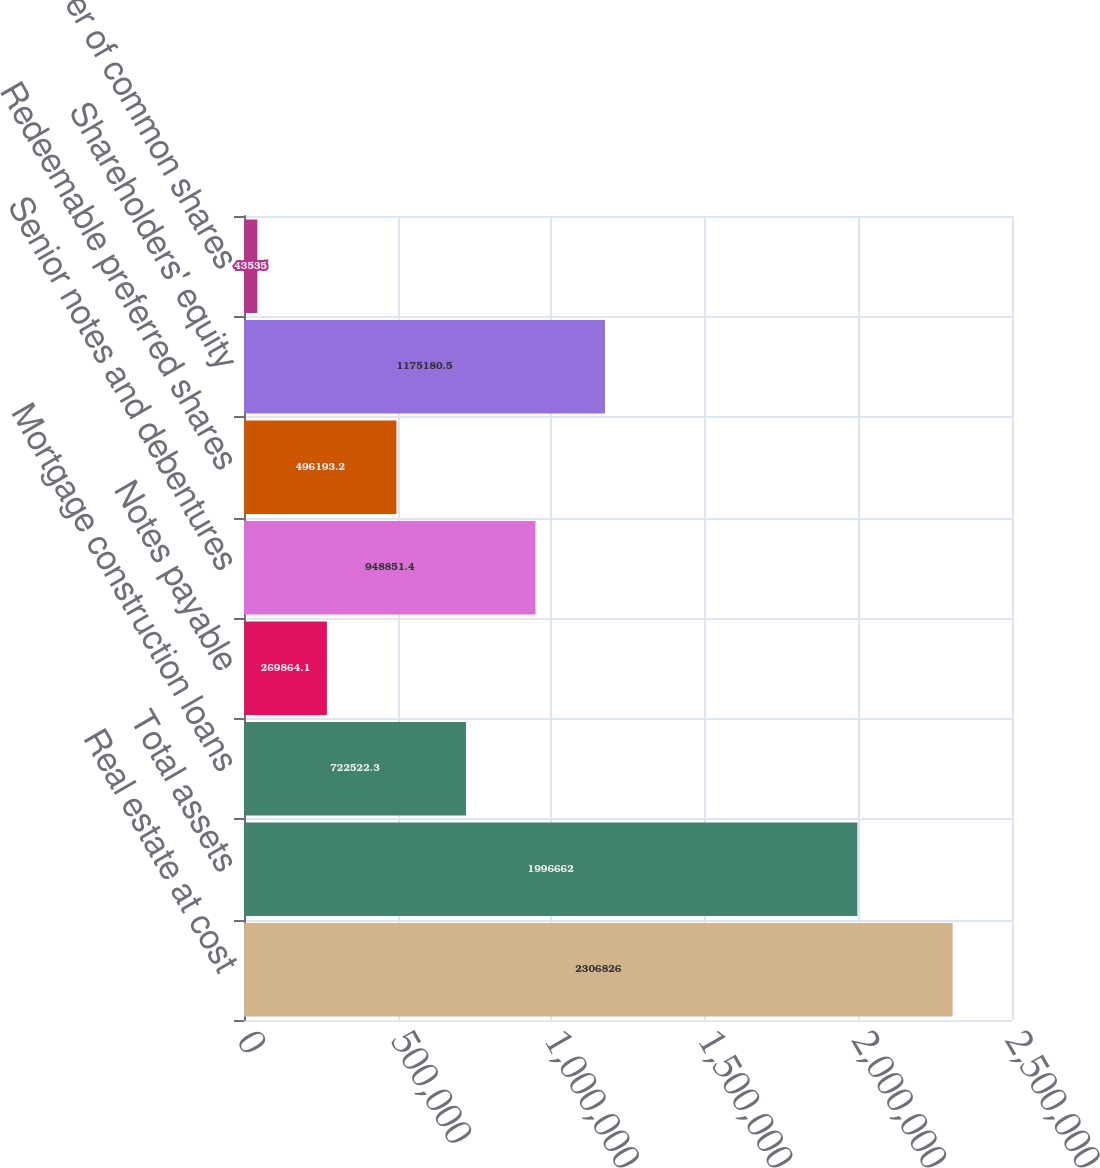<chart> <loc_0><loc_0><loc_500><loc_500><bar_chart><fcel>Real estate at cost<fcel>Total assets<fcel>Mortgage construction loans<fcel>Notes payable<fcel>Senior notes and debentures<fcel>Redeemable preferred shares<fcel>Shareholders' equity<fcel>Number of common shares<nl><fcel>2.30683e+06<fcel>1.99666e+06<fcel>722522<fcel>269864<fcel>948851<fcel>496193<fcel>1.17518e+06<fcel>43535<nl></chart> 